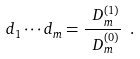<formula> <loc_0><loc_0><loc_500><loc_500>d _ { 1 } \cdots d _ { m } = \frac { \ D _ { m } ^ { ( 1 ) } } { \ D _ { m } ^ { ( 0 ) } } \ .</formula> 